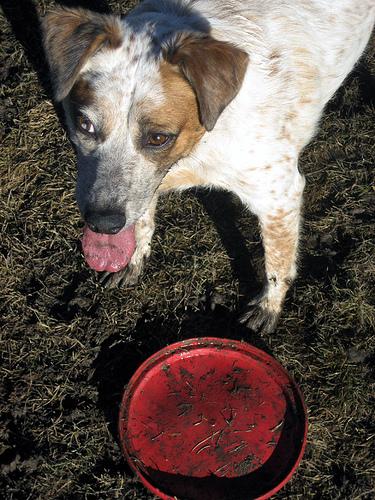Does this dog like to play?
Short answer required. Yes. Are the dogs eyes the same color?
Short answer required. No. What color is this dog?
Concise answer only. Brown and white. 